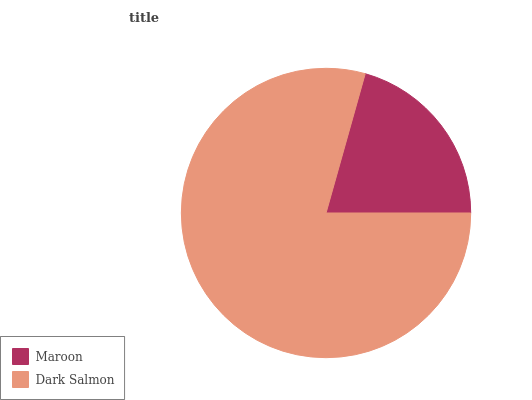Is Maroon the minimum?
Answer yes or no. Yes. Is Dark Salmon the maximum?
Answer yes or no. Yes. Is Dark Salmon the minimum?
Answer yes or no. No. Is Dark Salmon greater than Maroon?
Answer yes or no. Yes. Is Maroon less than Dark Salmon?
Answer yes or no. Yes. Is Maroon greater than Dark Salmon?
Answer yes or no. No. Is Dark Salmon less than Maroon?
Answer yes or no. No. Is Dark Salmon the high median?
Answer yes or no. Yes. Is Maroon the low median?
Answer yes or no. Yes. Is Maroon the high median?
Answer yes or no. No. Is Dark Salmon the low median?
Answer yes or no. No. 